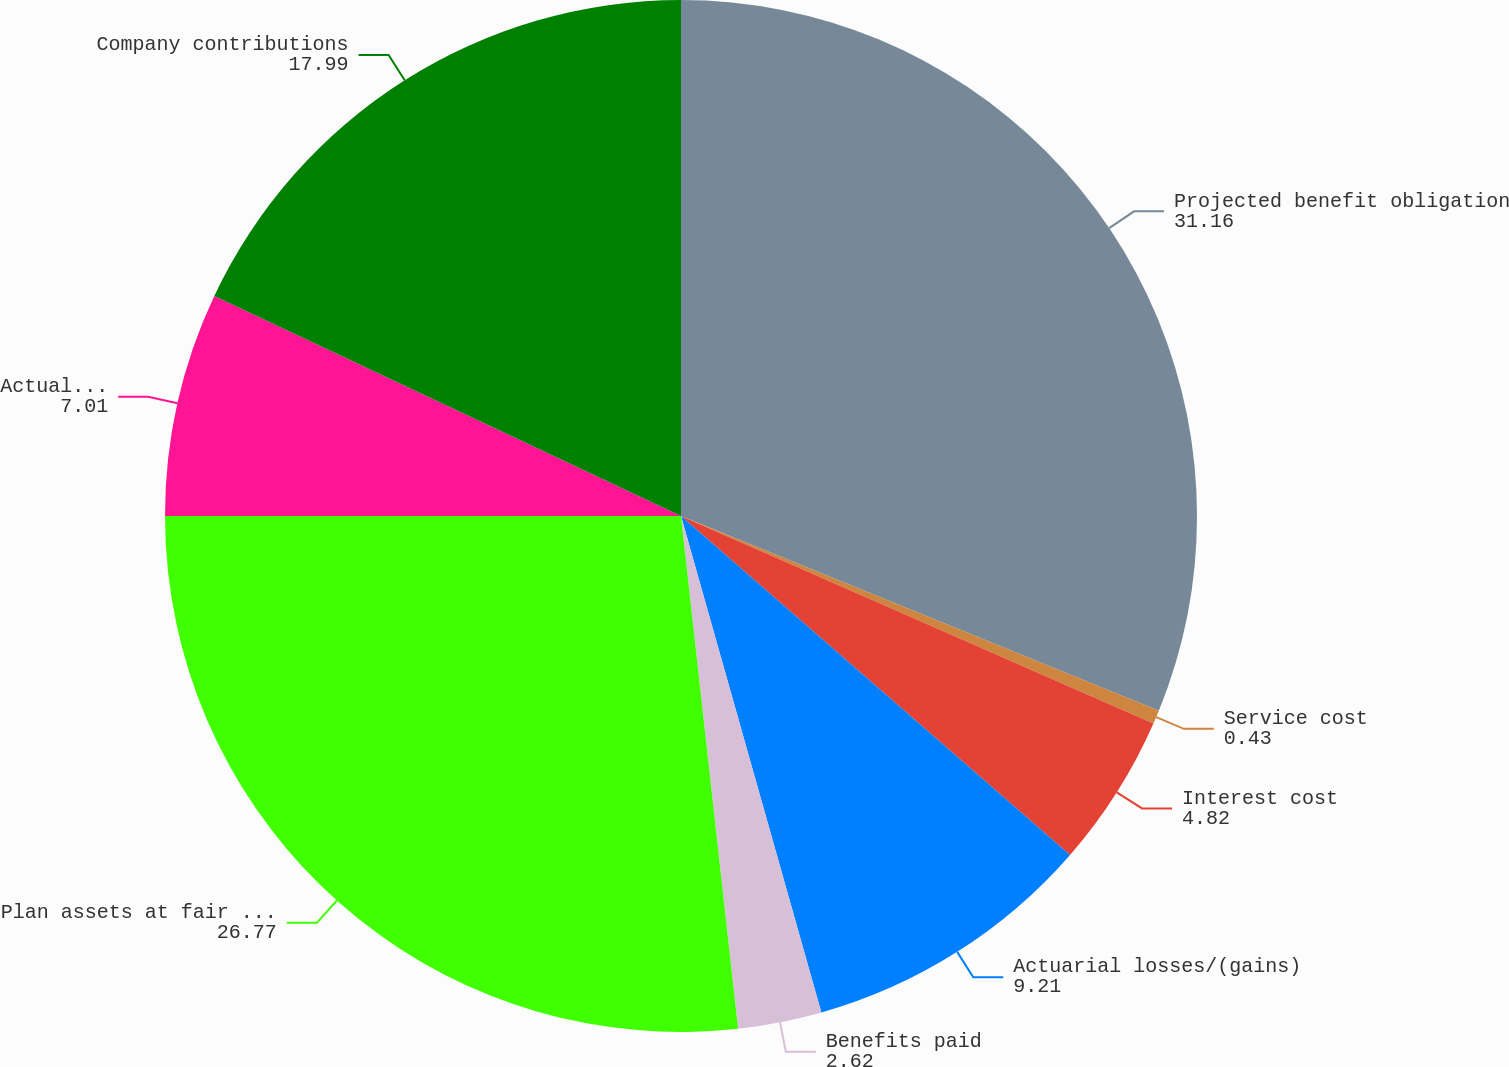Convert chart. <chart><loc_0><loc_0><loc_500><loc_500><pie_chart><fcel>Projected benefit obligation<fcel>Service cost<fcel>Interest cost<fcel>Actuarial losses/(gains)<fcel>Benefits paid<fcel>Plan assets at fair value at<fcel>Actual return/(loss) on plan<fcel>Company contributions<nl><fcel>31.16%<fcel>0.43%<fcel>4.82%<fcel>9.21%<fcel>2.62%<fcel>26.77%<fcel>7.01%<fcel>17.99%<nl></chart> 